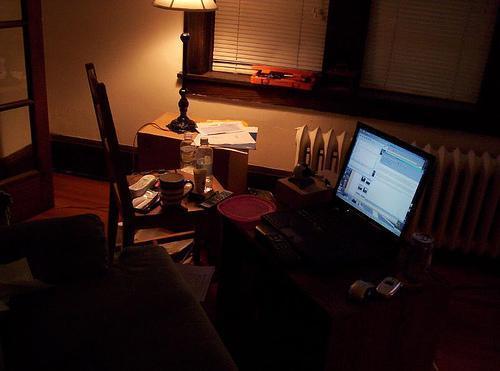How many computers are there?
Give a very brief answer. 1. How many plastic bottles are there?
Give a very brief answer. 2. 